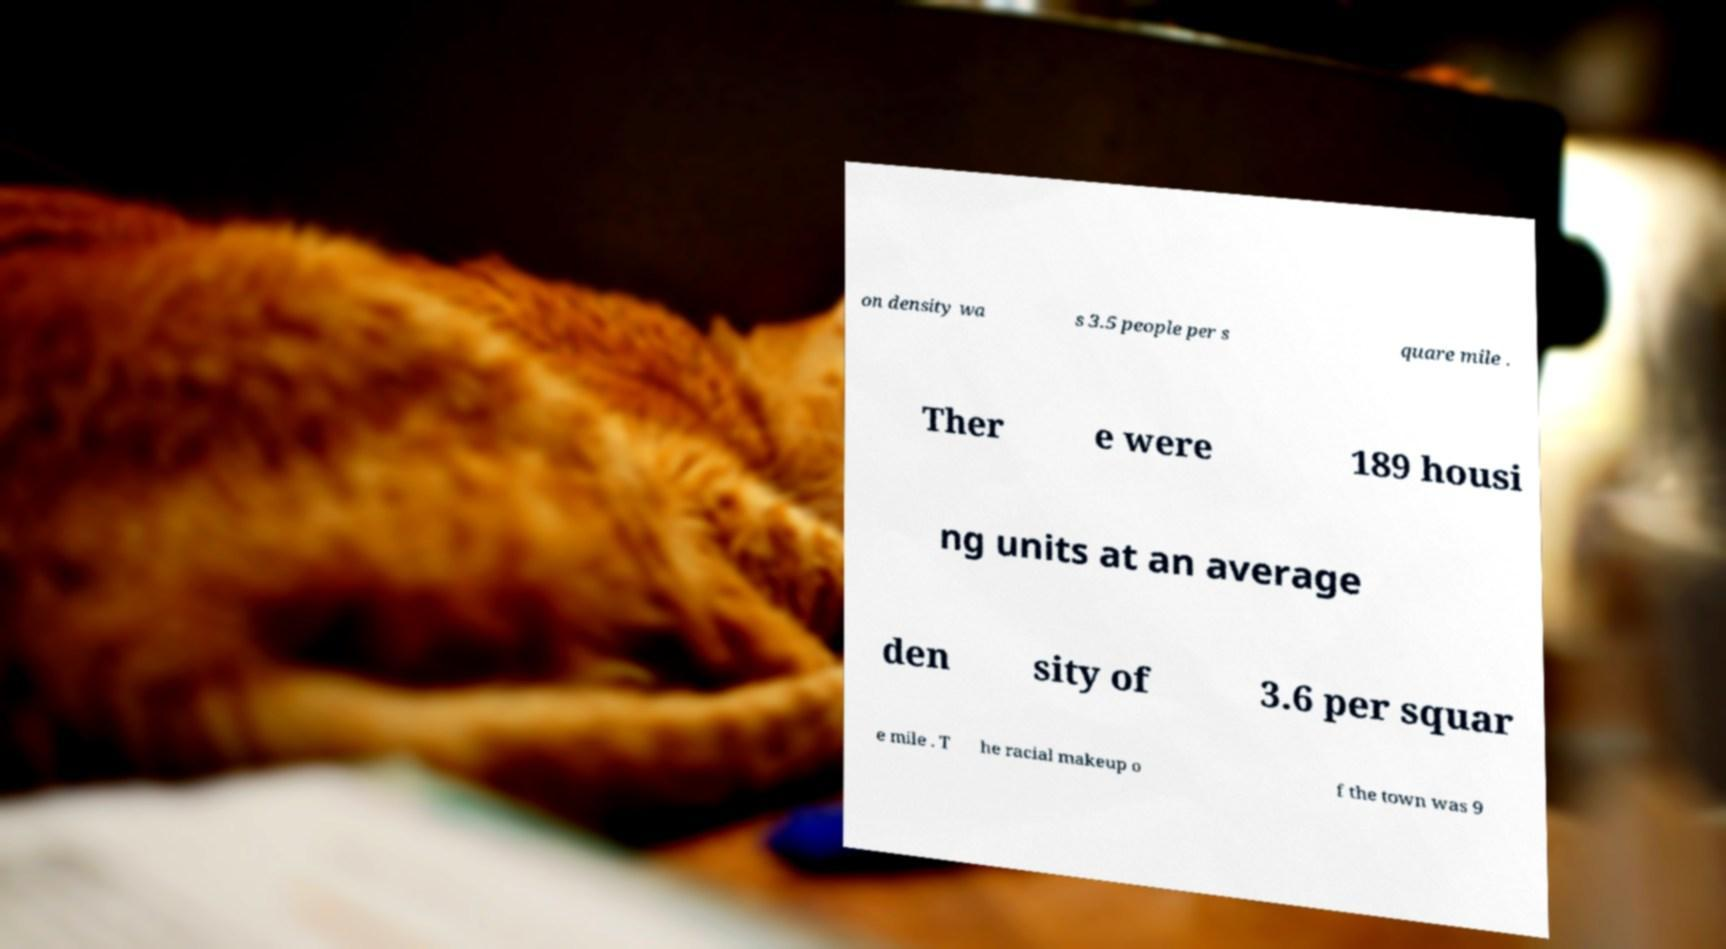What messages or text are displayed in this image? I need them in a readable, typed format. on density wa s 3.5 people per s quare mile . Ther e were 189 housi ng units at an average den sity of 3.6 per squar e mile . T he racial makeup o f the town was 9 